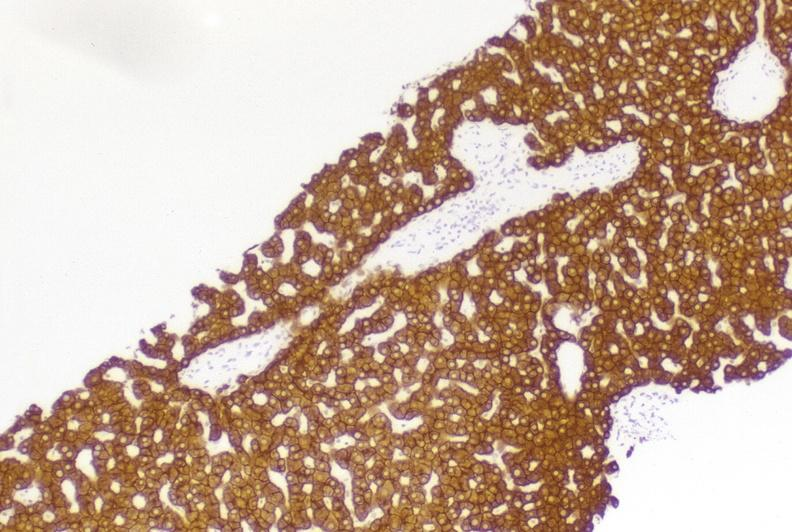does rheumatoid arthritis show high molecular weight keratin?
Answer the question using a single word or phrase. No 